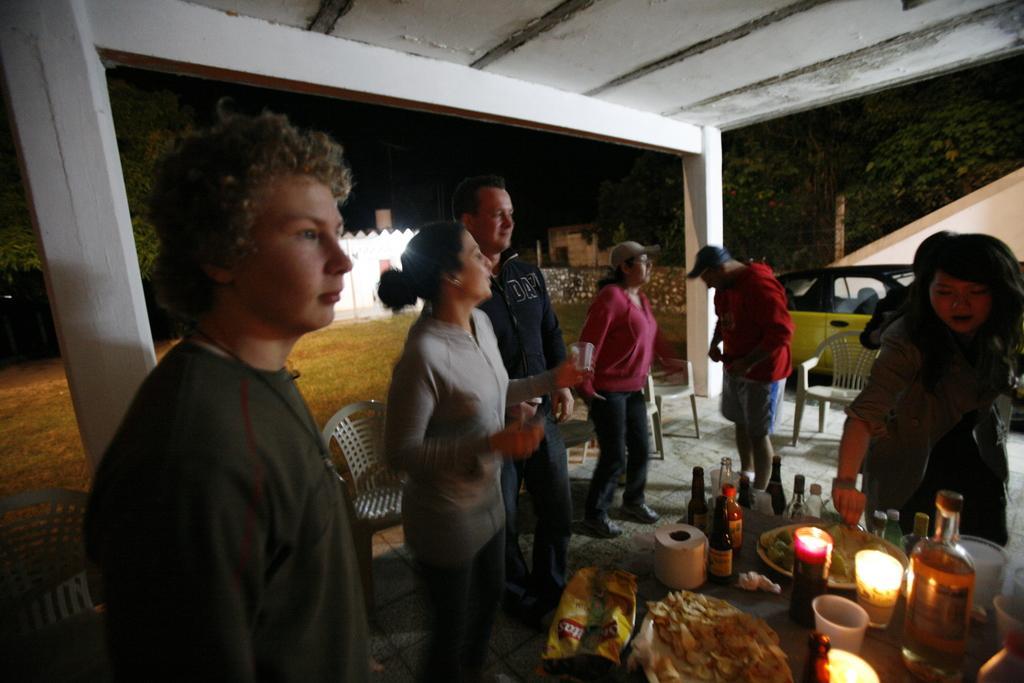Please provide a concise description of this image. In this image there a few people standing. Behind them there are chairs. In front of them there is a table. On the table there are bottles, candles, glasses, plates, food, food packets and tissues. Behind the chairs there's grass on the ground. To the right there is a car behind them. In the background there are trees and a house. At the top there is the ceiling. 